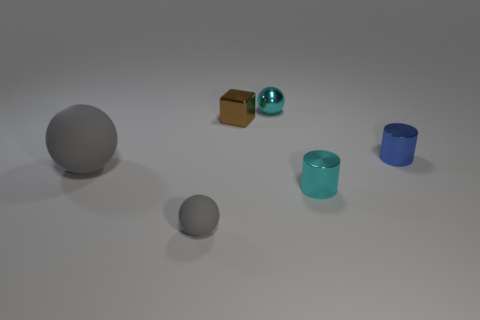What size is the sphere that is behind the gray rubber sphere that is left of the tiny sphere that is in front of the cube?
Your answer should be very brief. Small. What is the shape of the small matte object to the left of the thing behind the cube?
Give a very brief answer. Sphere. Is the color of the cylinder in front of the blue cylinder the same as the small matte thing?
Make the answer very short. No. The thing that is both on the right side of the small cyan shiny ball and in front of the blue cylinder is what color?
Make the answer very short. Cyan. Are there any red things that have the same material as the cyan cylinder?
Give a very brief answer. No. The cyan shiny cylinder has what size?
Give a very brief answer. Small. What size is the matte thing left of the tiny sphere in front of the cyan metal cylinder?
Provide a succinct answer. Large. There is another cyan object that is the same shape as the large object; what is it made of?
Your answer should be very brief. Metal. How many gray rubber things are there?
Your answer should be very brief. 2. What is the color of the small sphere that is to the left of the cyan metal thing that is behind the gray rubber object that is on the left side of the small matte thing?
Provide a short and direct response. Gray. 